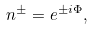Convert formula to latex. <formula><loc_0><loc_0><loc_500><loc_500>n ^ { \pm } = e ^ { \pm i \Phi } ,</formula> 